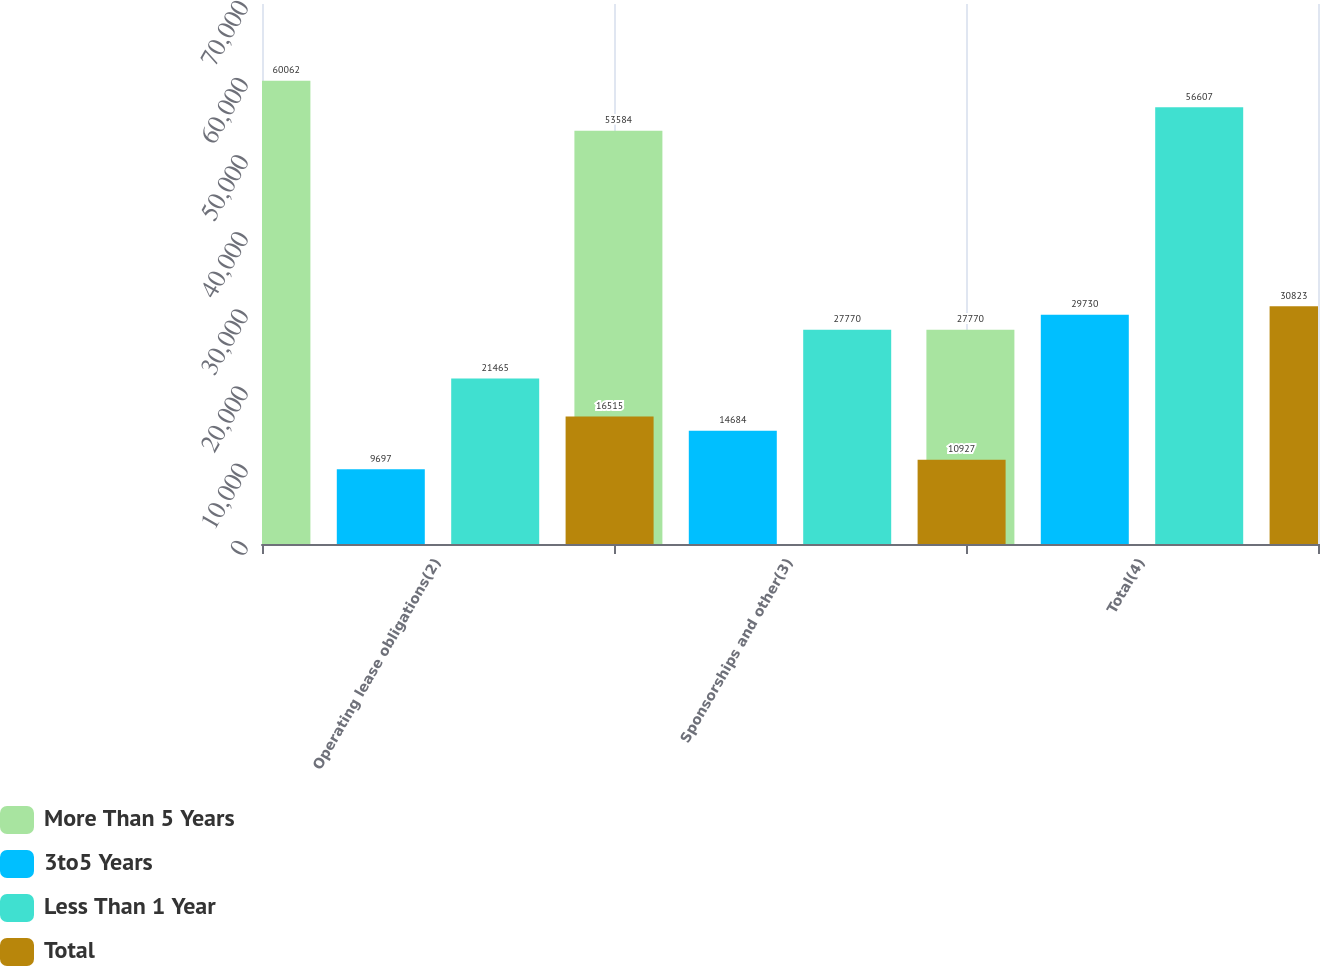<chart> <loc_0><loc_0><loc_500><loc_500><stacked_bar_chart><ecel><fcel>Operating lease obligations(2)<fcel>Sponsorships and other(3)<fcel>Total(4)<nl><fcel>More Than 5 Years<fcel>60062<fcel>53584<fcel>27770<nl><fcel>3to5 Years<fcel>9697<fcel>14684<fcel>29730<nl><fcel>Less Than 1 Year<fcel>21465<fcel>27770<fcel>56607<nl><fcel>Total<fcel>16515<fcel>10927<fcel>30823<nl></chart> 